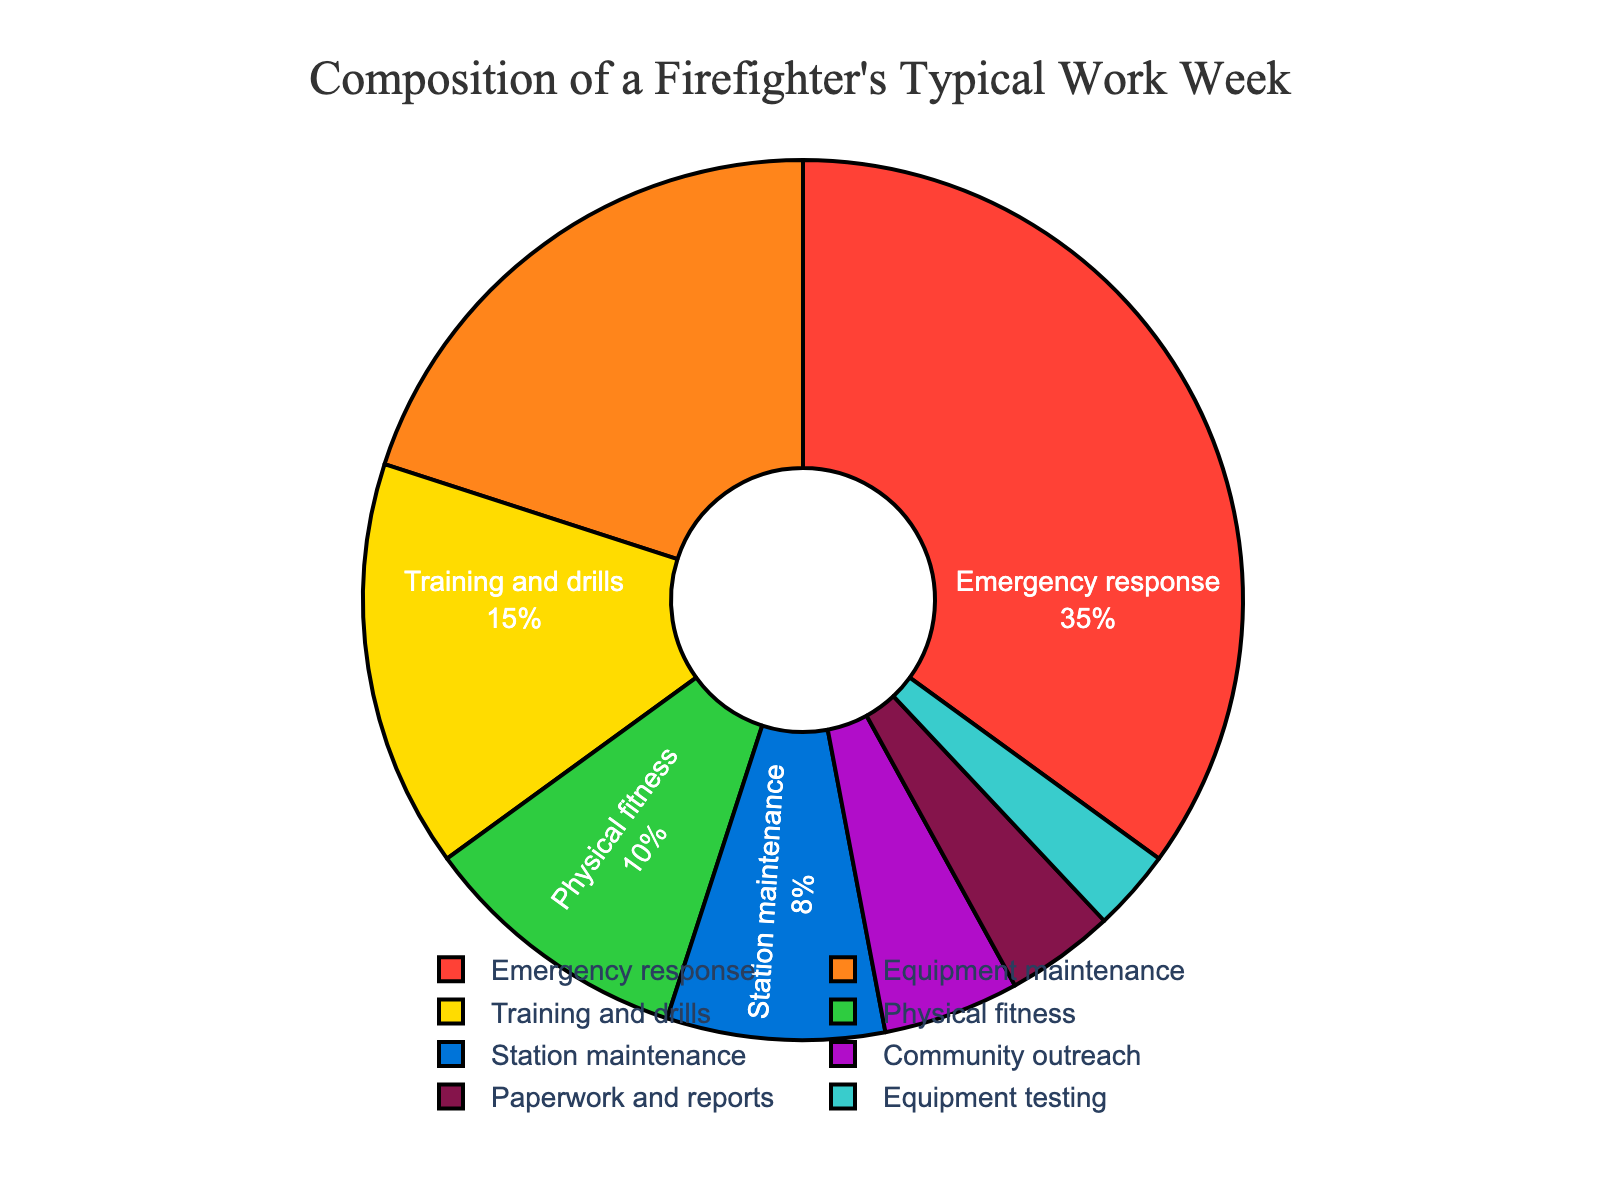What percentage of a firefighter's week is spent on physical or station maintenance combined? Add the percentages for physical fitness and station maintenance: 10% + 8% = 18%.
Answer: 18% Which activity takes up the most time in a firefighter's work week? Look for the activity with the highest percentage, which is emergency response at 35%.
Answer: Emergency response How much more time is spent on equipment maintenance than on training and drills? Subtract the percentage for training and drills from the percentage for equipment maintenance: 20% - 15% = 5%.
Answer: 5% What are the two activities that together make up exactly half of a firefighter's work week? Sum the percentage of activities until 50% is reached: Equipment maintenance (20%) + Emergency response (35%) = 55%. The largest exact combination under 50% is Emergency response (35%) + Training and drills (15%) = 50%.
Answer: Emergency response, Training and drills How does the percentage of time spent on paperwork and reports compare with community outreach? Compare the percentages: paperwork and reports (4%) < community outreach (5%).
Answer: Community outreach is higher What is the sum of the three activities with the lowest percentages? Sum the percentages of paperwork and reports (4%), equipment testing (3%), and community outreach (5%): 4% + 3% + 5% = 12%.
Answer: 12% Which activity's percentage is close to the percentage for physical fitness? Compare with physical fitness (10%). The closest is station maintenance (8%).
Answer: Station maintenance What color represents the equipment maintenance section? Identify the color visually assigned to the equipment maintenance segment. According to the code, it is orange.
Answer: Orange If you combine the time spent on emergency response and training and drills, how much more time is spent on these activities compared to station maintenance and paperwork and reports combined? Sum the percentages for emergency response (35%) and training and drills (15%): 35% + 15% = 50%. Sum for station maintenance (8%) and paperwork and reports (4%): 8% + 4% = 12%. The difference is 50% - 12% = 38%.
Answer: 38% 